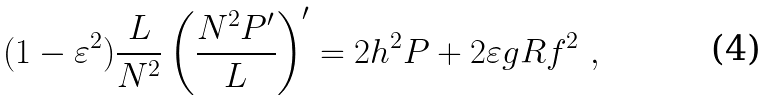Convert formula to latex. <formula><loc_0><loc_0><loc_500><loc_500>( 1 - \varepsilon ^ { 2 } ) \frac { L } { N ^ { 2 } } \left ( \frac { N ^ { 2 } P ^ { \prime } } { L } \right ) ^ { \prime } = 2 h ^ { 2 } P + 2 \varepsilon g R f ^ { 2 } \ ,</formula> 